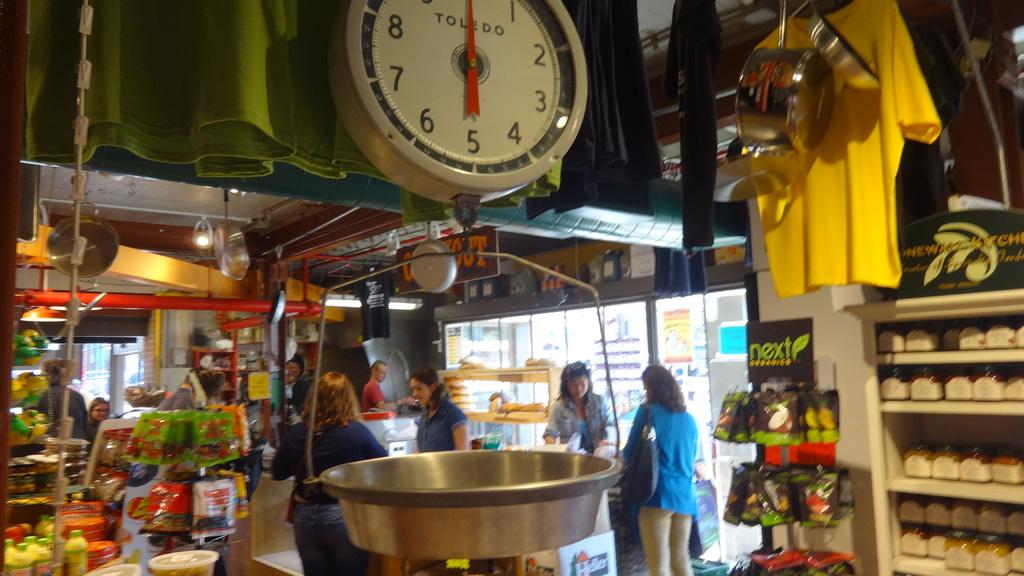What brand is the scale?
Provide a short and direct response. Toledo. 